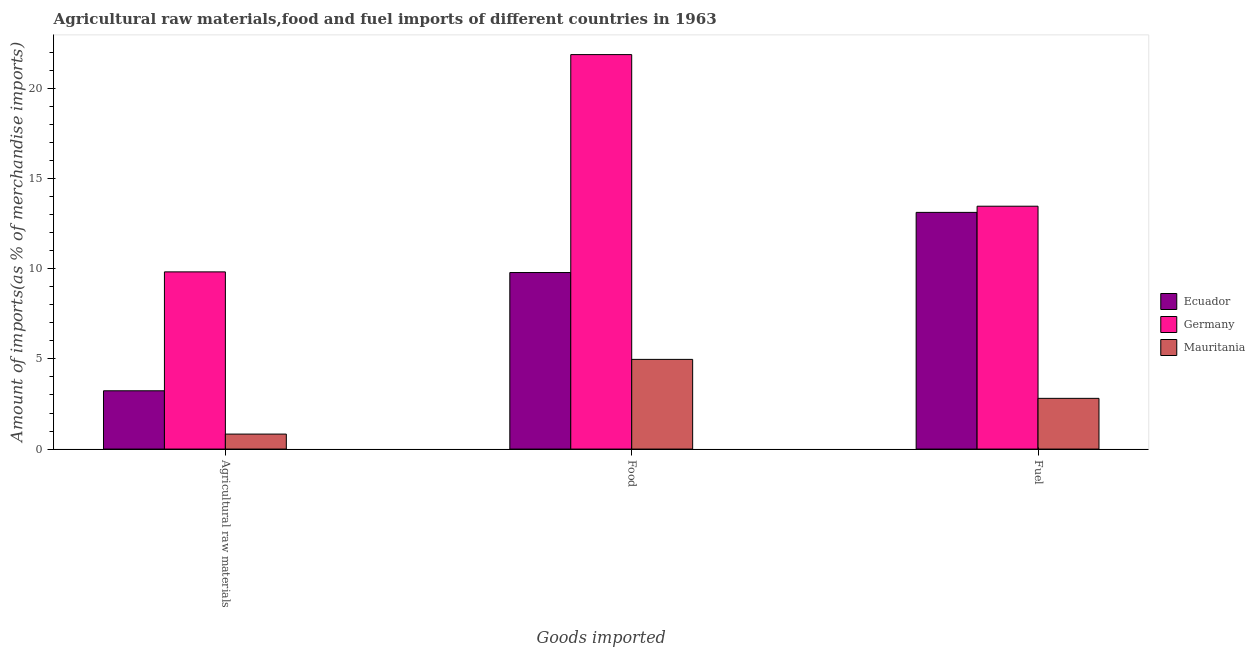How many different coloured bars are there?
Your answer should be compact. 3. How many groups of bars are there?
Provide a short and direct response. 3. Are the number of bars per tick equal to the number of legend labels?
Offer a very short reply. Yes. How many bars are there on the 2nd tick from the right?
Your answer should be very brief. 3. What is the label of the 2nd group of bars from the left?
Make the answer very short. Food. What is the percentage of food imports in Ecuador?
Your answer should be compact. 9.79. Across all countries, what is the maximum percentage of food imports?
Make the answer very short. 21.88. Across all countries, what is the minimum percentage of raw materials imports?
Offer a terse response. 0.83. In which country was the percentage of fuel imports maximum?
Offer a terse response. Germany. In which country was the percentage of fuel imports minimum?
Give a very brief answer. Mauritania. What is the total percentage of raw materials imports in the graph?
Offer a very short reply. 13.89. What is the difference between the percentage of food imports in Mauritania and that in Germany?
Make the answer very short. -16.9. What is the difference between the percentage of food imports in Mauritania and the percentage of fuel imports in Ecuador?
Provide a short and direct response. -8.15. What is the average percentage of fuel imports per country?
Make the answer very short. 9.8. What is the difference between the percentage of fuel imports and percentage of food imports in Mauritania?
Provide a short and direct response. -2.16. What is the ratio of the percentage of food imports in Ecuador to that in Germany?
Give a very brief answer. 0.45. Is the difference between the percentage of fuel imports in Germany and Ecuador greater than the difference between the percentage of food imports in Germany and Ecuador?
Ensure brevity in your answer.  No. What is the difference between the highest and the second highest percentage of raw materials imports?
Provide a short and direct response. 6.6. What is the difference between the highest and the lowest percentage of raw materials imports?
Give a very brief answer. 9. In how many countries, is the percentage of fuel imports greater than the average percentage of fuel imports taken over all countries?
Offer a very short reply. 2. What does the 2nd bar from the left in Agricultural raw materials represents?
Offer a very short reply. Germany. What does the 3rd bar from the right in Food represents?
Offer a very short reply. Ecuador. Is it the case that in every country, the sum of the percentage of raw materials imports and percentage of food imports is greater than the percentage of fuel imports?
Your answer should be very brief. No. How many bars are there?
Ensure brevity in your answer.  9. Are all the bars in the graph horizontal?
Provide a succinct answer. No. How many countries are there in the graph?
Make the answer very short. 3. What is the difference between two consecutive major ticks on the Y-axis?
Ensure brevity in your answer.  5. Are the values on the major ticks of Y-axis written in scientific E-notation?
Your response must be concise. No. Does the graph contain any zero values?
Provide a succinct answer. No. Does the graph contain grids?
Provide a succinct answer. No. Where does the legend appear in the graph?
Provide a short and direct response. Center right. How many legend labels are there?
Provide a short and direct response. 3. What is the title of the graph?
Offer a very short reply. Agricultural raw materials,food and fuel imports of different countries in 1963. Does "Malta" appear as one of the legend labels in the graph?
Make the answer very short. No. What is the label or title of the X-axis?
Give a very brief answer. Goods imported. What is the label or title of the Y-axis?
Keep it short and to the point. Amount of imports(as % of merchandise imports). What is the Amount of imports(as % of merchandise imports) in Ecuador in Agricultural raw materials?
Offer a very short reply. 3.23. What is the Amount of imports(as % of merchandise imports) in Germany in Agricultural raw materials?
Make the answer very short. 9.83. What is the Amount of imports(as % of merchandise imports) of Mauritania in Agricultural raw materials?
Your answer should be very brief. 0.83. What is the Amount of imports(as % of merchandise imports) in Ecuador in Food?
Offer a terse response. 9.79. What is the Amount of imports(as % of merchandise imports) in Germany in Food?
Offer a very short reply. 21.88. What is the Amount of imports(as % of merchandise imports) in Mauritania in Food?
Your answer should be compact. 4.97. What is the Amount of imports(as % of merchandise imports) in Ecuador in Fuel?
Ensure brevity in your answer.  13.13. What is the Amount of imports(as % of merchandise imports) in Germany in Fuel?
Your answer should be very brief. 13.47. What is the Amount of imports(as % of merchandise imports) in Mauritania in Fuel?
Make the answer very short. 2.81. Across all Goods imported, what is the maximum Amount of imports(as % of merchandise imports) in Ecuador?
Give a very brief answer. 13.13. Across all Goods imported, what is the maximum Amount of imports(as % of merchandise imports) of Germany?
Provide a short and direct response. 21.88. Across all Goods imported, what is the maximum Amount of imports(as % of merchandise imports) of Mauritania?
Offer a terse response. 4.97. Across all Goods imported, what is the minimum Amount of imports(as % of merchandise imports) of Ecuador?
Ensure brevity in your answer.  3.23. Across all Goods imported, what is the minimum Amount of imports(as % of merchandise imports) of Germany?
Make the answer very short. 9.83. Across all Goods imported, what is the minimum Amount of imports(as % of merchandise imports) of Mauritania?
Offer a very short reply. 0.83. What is the total Amount of imports(as % of merchandise imports) of Ecuador in the graph?
Provide a succinct answer. 26.15. What is the total Amount of imports(as % of merchandise imports) of Germany in the graph?
Provide a short and direct response. 45.18. What is the total Amount of imports(as % of merchandise imports) of Mauritania in the graph?
Provide a succinct answer. 8.62. What is the difference between the Amount of imports(as % of merchandise imports) in Ecuador in Agricultural raw materials and that in Food?
Keep it short and to the point. -6.56. What is the difference between the Amount of imports(as % of merchandise imports) of Germany in Agricultural raw materials and that in Food?
Offer a terse response. -12.05. What is the difference between the Amount of imports(as % of merchandise imports) in Mauritania in Agricultural raw materials and that in Food?
Offer a terse response. -4.14. What is the difference between the Amount of imports(as % of merchandise imports) of Ecuador in Agricultural raw materials and that in Fuel?
Ensure brevity in your answer.  -9.89. What is the difference between the Amount of imports(as % of merchandise imports) in Germany in Agricultural raw materials and that in Fuel?
Your response must be concise. -3.64. What is the difference between the Amount of imports(as % of merchandise imports) in Mauritania in Agricultural raw materials and that in Fuel?
Your answer should be very brief. -1.98. What is the difference between the Amount of imports(as % of merchandise imports) of Ecuador in Food and that in Fuel?
Ensure brevity in your answer.  -3.34. What is the difference between the Amount of imports(as % of merchandise imports) of Germany in Food and that in Fuel?
Offer a very short reply. 8.41. What is the difference between the Amount of imports(as % of merchandise imports) in Mauritania in Food and that in Fuel?
Offer a very short reply. 2.16. What is the difference between the Amount of imports(as % of merchandise imports) in Ecuador in Agricultural raw materials and the Amount of imports(as % of merchandise imports) in Germany in Food?
Offer a very short reply. -18.65. What is the difference between the Amount of imports(as % of merchandise imports) in Ecuador in Agricultural raw materials and the Amount of imports(as % of merchandise imports) in Mauritania in Food?
Make the answer very short. -1.74. What is the difference between the Amount of imports(as % of merchandise imports) in Germany in Agricultural raw materials and the Amount of imports(as % of merchandise imports) in Mauritania in Food?
Provide a short and direct response. 4.85. What is the difference between the Amount of imports(as % of merchandise imports) of Ecuador in Agricultural raw materials and the Amount of imports(as % of merchandise imports) of Germany in Fuel?
Ensure brevity in your answer.  -10.24. What is the difference between the Amount of imports(as % of merchandise imports) of Ecuador in Agricultural raw materials and the Amount of imports(as % of merchandise imports) of Mauritania in Fuel?
Give a very brief answer. 0.42. What is the difference between the Amount of imports(as % of merchandise imports) of Germany in Agricultural raw materials and the Amount of imports(as % of merchandise imports) of Mauritania in Fuel?
Keep it short and to the point. 7.01. What is the difference between the Amount of imports(as % of merchandise imports) of Ecuador in Food and the Amount of imports(as % of merchandise imports) of Germany in Fuel?
Provide a short and direct response. -3.68. What is the difference between the Amount of imports(as % of merchandise imports) in Ecuador in Food and the Amount of imports(as % of merchandise imports) in Mauritania in Fuel?
Ensure brevity in your answer.  6.98. What is the difference between the Amount of imports(as % of merchandise imports) of Germany in Food and the Amount of imports(as % of merchandise imports) of Mauritania in Fuel?
Your answer should be very brief. 19.07. What is the average Amount of imports(as % of merchandise imports) of Ecuador per Goods imported?
Provide a succinct answer. 8.72. What is the average Amount of imports(as % of merchandise imports) in Germany per Goods imported?
Offer a very short reply. 15.06. What is the average Amount of imports(as % of merchandise imports) of Mauritania per Goods imported?
Make the answer very short. 2.87. What is the difference between the Amount of imports(as % of merchandise imports) in Ecuador and Amount of imports(as % of merchandise imports) in Germany in Agricultural raw materials?
Ensure brevity in your answer.  -6.6. What is the difference between the Amount of imports(as % of merchandise imports) of Ecuador and Amount of imports(as % of merchandise imports) of Mauritania in Agricultural raw materials?
Provide a short and direct response. 2.4. What is the difference between the Amount of imports(as % of merchandise imports) of Germany and Amount of imports(as % of merchandise imports) of Mauritania in Agricultural raw materials?
Your response must be concise. 9. What is the difference between the Amount of imports(as % of merchandise imports) of Ecuador and Amount of imports(as % of merchandise imports) of Germany in Food?
Ensure brevity in your answer.  -12.09. What is the difference between the Amount of imports(as % of merchandise imports) of Ecuador and Amount of imports(as % of merchandise imports) of Mauritania in Food?
Your answer should be compact. 4.82. What is the difference between the Amount of imports(as % of merchandise imports) in Germany and Amount of imports(as % of merchandise imports) in Mauritania in Food?
Provide a short and direct response. 16.9. What is the difference between the Amount of imports(as % of merchandise imports) of Ecuador and Amount of imports(as % of merchandise imports) of Germany in Fuel?
Give a very brief answer. -0.34. What is the difference between the Amount of imports(as % of merchandise imports) in Ecuador and Amount of imports(as % of merchandise imports) in Mauritania in Fuel?
Provide a succinct answer. 10.31. What is the difference between the Amount of imports(as % of merchandise imports) of Germany and Amount of imports(as % of merchandise imports) of Mauritania in Fuel?
Provide a short and direct response. 10.66. What is the ratio of the Amount of imports(as % of merchandise imports) of Ecuador in Agricultural raw materials to that in Food?
Your answer should be very brief. 0.33. What is the ratio of the Amount of imports(as % of merchandise imports) of Germany in Agricultural raw materials to that in Food?
Your answer should be compact. 0.45. What is the ratio of the Amount of imports(as % of merchandise imports) in Mauritania in Agricultural raw materials to that in Food?
Provide a succinct answer. 0.17. What is the ratio of the Amount of imports(as % of merchandise imports) in Ecuador in Agricultural raw materials to that in Fuel?
Make the answer very short. 0.25. What is the ratio of the Amount of imports(as % of merchandise imports) in Germany in Agricultural raw materials to that in Fuel?
Provide a short and direct response. 0.73. What is the ratio of the Amount of imports(as % of merchandise imports) of Mauritania in Agricultural raw materials to that in Fuel?
Offer a terse response. 0.3. What is the ratio of the Amount of imports(as % of merchandise imports) in Ecuador in Food to that in Fuel?
Ensure brevity in your answer.  0.75. What is the ratio of the Amount of imports(as % of merchandise imports) in Germany in Food to that in Fuel?
Your answer should be compact. 1.62. What is the ratio of the Amount of imports(as % of merchandise imports) in Mauritania in Food to that in Fuel?
Give a very brief answer. 1.77. What is the difference between the highest and the second highest Amount of imports(as % of merchandise imports) of Ecuador?
Keep it short and to the point. 3.34. What is the difference between the highest and the second highest Amount of imports(as % of merchandise imports) in Germany?
Your response must be concise. 8.41. What is the difference between the highest and the second highest Amount of imports(as % of merchandise imports) in Mauritania?
Your response must be concise. 2.16. What is the difference between the highest and the lowest Amount of imports(as % of merchandise imports) of Ecuador?
Give a very brief answer. 9.89. What is the difference between the highest and the lowest Amount of imports(as % of merchandise imports) in Germany?
Keep it short and to the point. 12.05. What is the difference between the highest and the lowest Amount of imports(as % of merchandise imports) of Mauritania?
Provide a short and direct response. 4.14. 